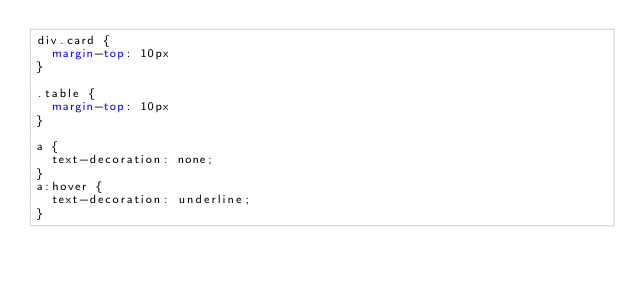Convert code to text. <code><loc_0><loc_0><loc_500><loc_500><_CSS_>div.card {
  margin-top: 10px
}

.table {
  margin-top: 10px
}

a {
  text-decoration: none; 
}
a:hover {
  text-decoration: underline;
}</code> 